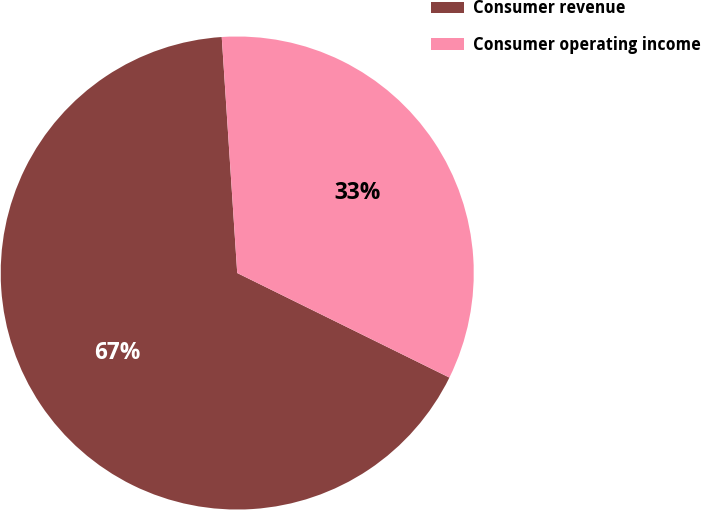Convert chart. <chart><loc_0><loc_0><loc_500><loc_500><pie_chart><fcel>Consumer revenue<fcel>Consumer operating income<nl><fcel>66.67%<fcel>33.33%<nl></chart> 